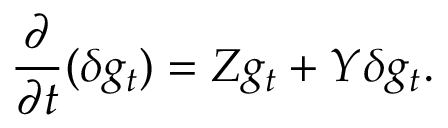Convert formula to latex. <formula><loc_0><loc_0><loc_500><loc_500>\frac { \partial } { \partial t } ( \delta g _ { t } ) = Z g _ { t } + Y \delta g _ { t } .</formula> 